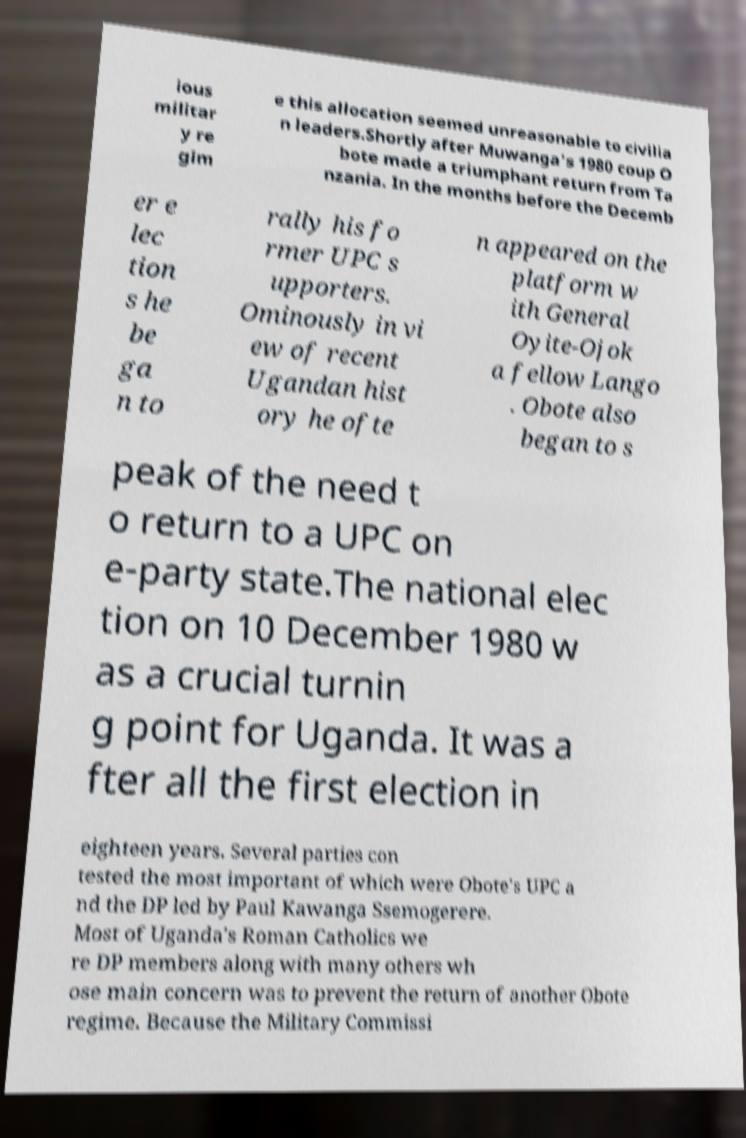Could you extract and type out the text from this image? ious militar y re gim e this allocation seemed unreasonable to civilia n leaders.Shortly after Muwanga's 1980 coup O bote made a triumphant return from Ta nzania. In the months before the Decemb er e lec tion s he be ga n to rally his fo rmer UPC s upporters. Ominously in vi ew of recent Ugandan hist ory he ofte n appeared on the platform w ith General Oyite-Ojok a fellow Lango . Obote also began to s peak of the need t o return to a UPC on e-party state.The national elec tion on 10 December 1980 w as a crucial turnin g point for Uganda. It was a fter all the first election in eighteen years. Several parties con tested the most important of which were Obote's UPC a nd the DP led by Paul Kawanga Ssemogerere. Most of Uganda's Roman Catholics we re DP members along with many others wh ose main concern was to prevent the return of another Obote regime. Because the Military Commissi 